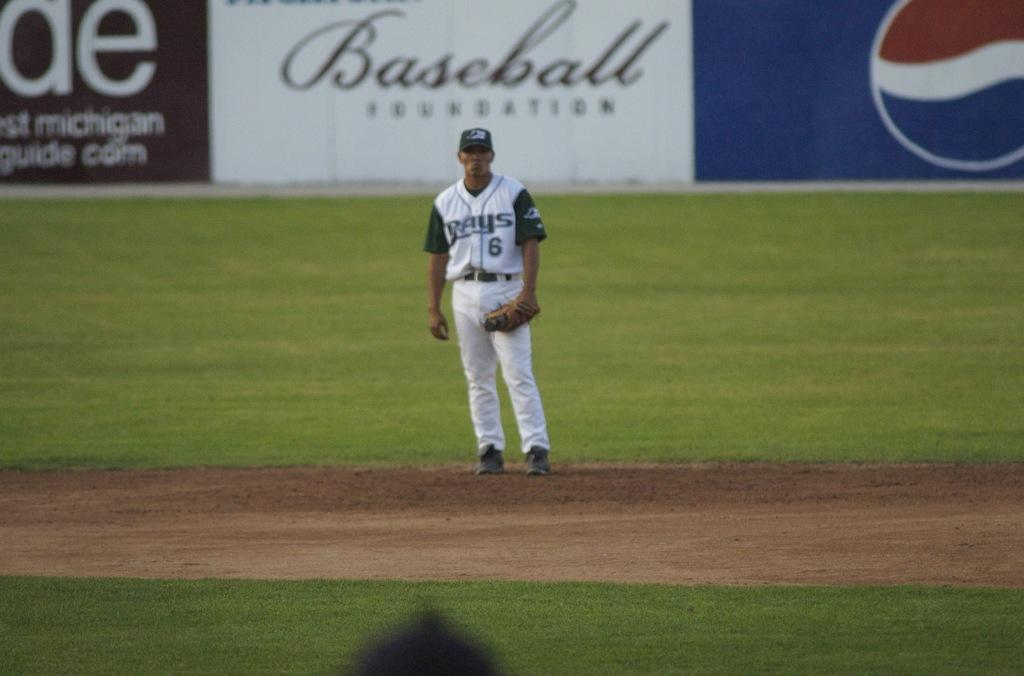<image>
Share a concise interpretation of the image provided. A man on a sports field with the word baseball behind him. 